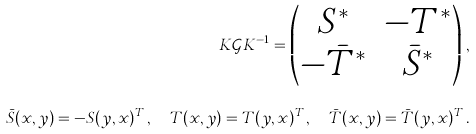Convert formula to latex. <formula><loc_0><loc_0><loc_500><loc_500>K \mathcal { G } K ^ { - 1 } = \begin{pmatrix} S ^ { * } & - T ^ { * } \\ - \bar { T } ^ { * } & \bar { S } ^ { * } \end{pmatrix} \, , \\ \bar { S } ( x , y ) = - S ( y , x ) ^ { T } \, , \quad T ( x , y ) = T ( y , x ) ^ { T } \, , \quad \bar { T } ( x , y ) = \bar { T } ( y , x ) ^ { T } \, .</formula> 